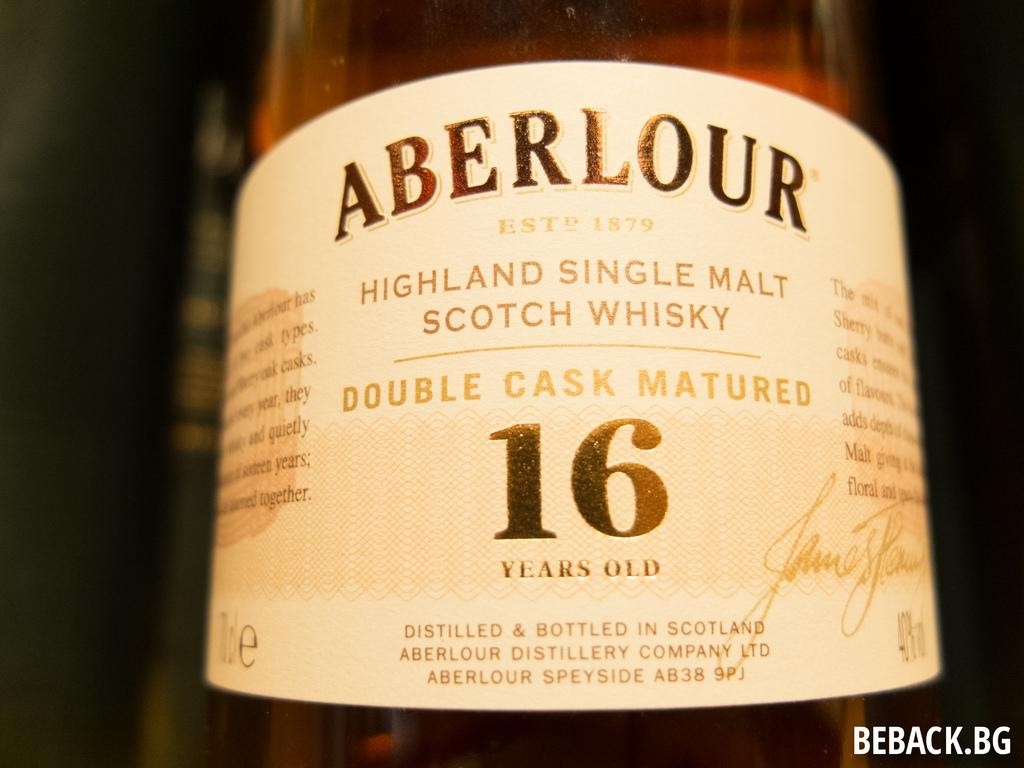Provide a one-sentence caption for the provided image. The 16 years old Highland single malt Scotch Whisky was produced by Aberlour, established 1879. 